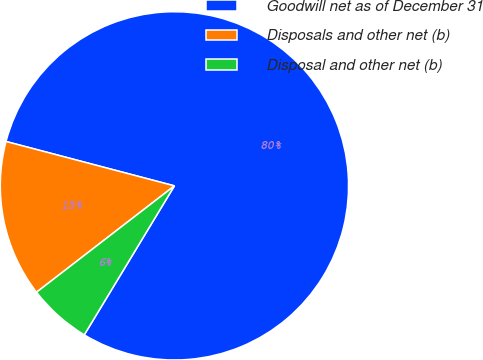Convert chart to OTSL. <chart><loc_0><loc_0><loc_500><loc_500><pie_chart><fcel>Goodwill net as of December 31<fcel>Disposals and other net (b)<fcel>Disposal and other net (b)<nl><fcel>79.56%<fcel>14.56%<fcel>5.88%<nl></chart> 